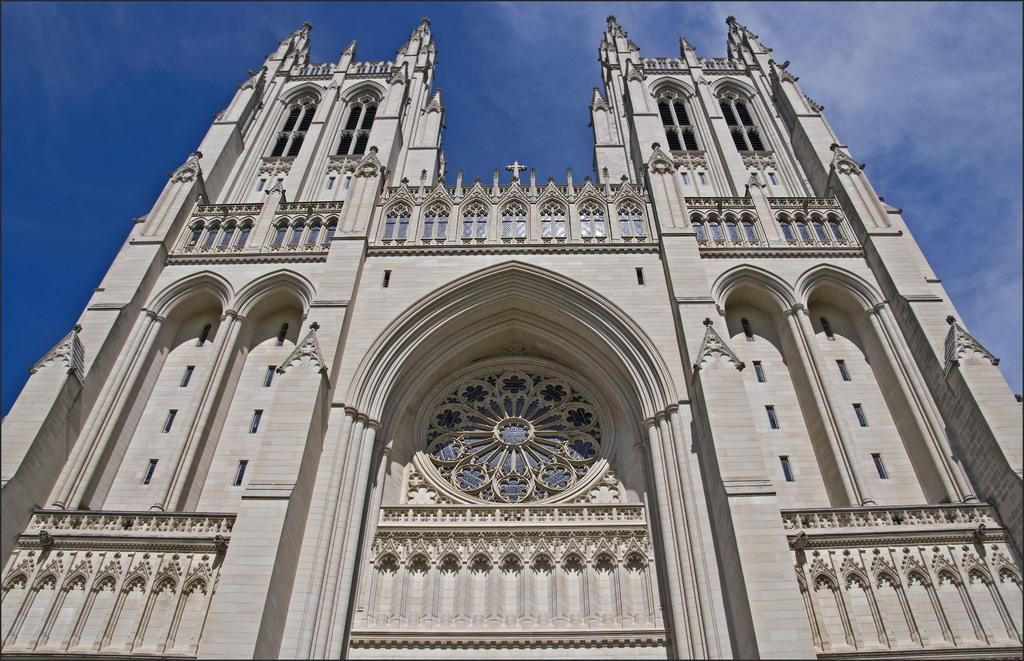What is the main subject in the center of the image? There is a building in the center of the image. What can be seen at the top of the image? The sky is visible at the top of the image. How many chess pieces can be seen on the building in the image? There are no chess pieces visible on the building in the image. What type of destruction can be seen happening to the building in the image? There is no destruction visible in the image; the building appears to be intact. 